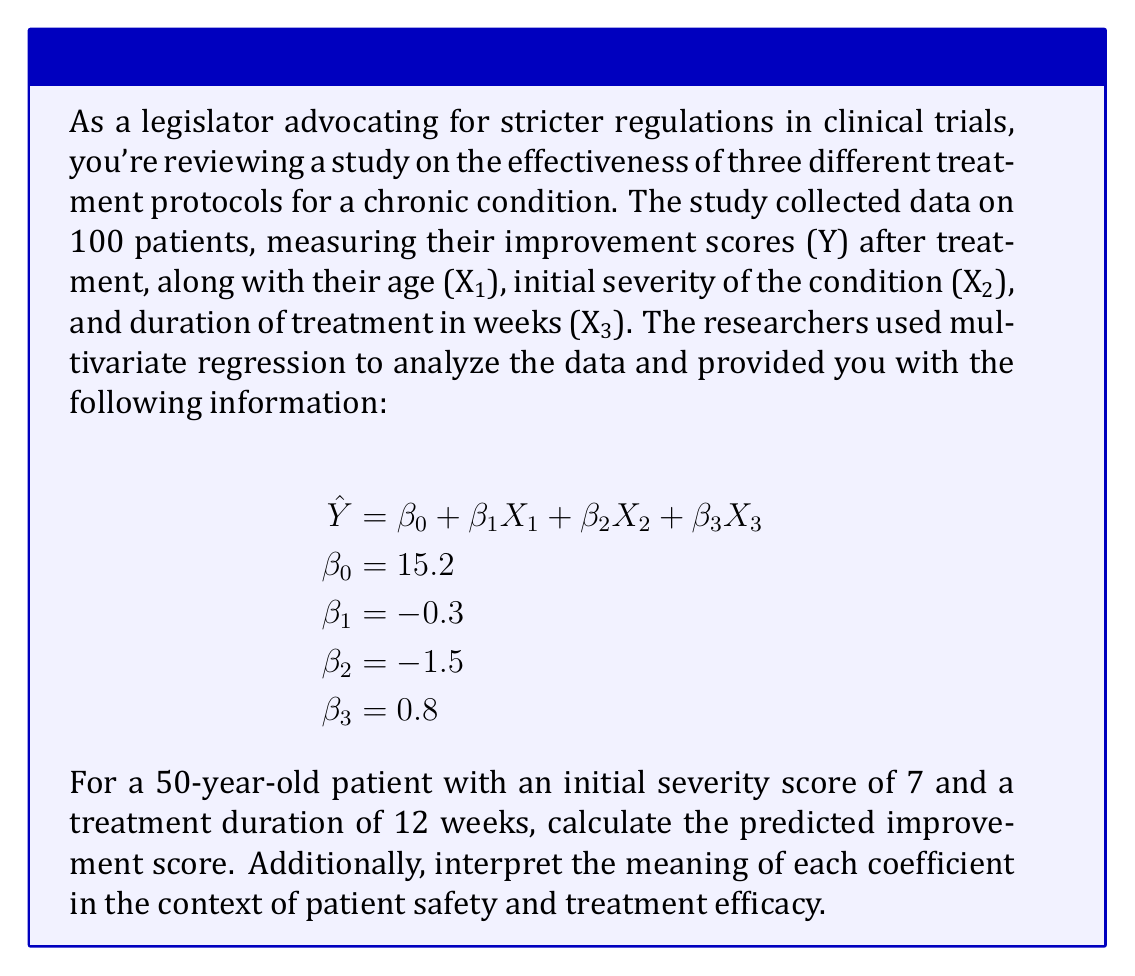Solve this math problem. To solve this problem and interpret the results, we'll follow these steps:

1. Calculate the predicted improvement score:
   We'll use the given regression equation and substitute the values for X1, X2, and X3.

   $$\begin{aligned}
   \hat{Y} &= \beta_0 + \beta_1X_1 + \beta_2X_2 + \beta_3X_3 \\
   &= 15.2 + (-0.3)(50) + (-1.5)(7) + (0.8)(12) \\
   &= 15.2 - 15 - 10.5 + 9.6 \\
   &= -0.7
   \end{aligned}$$

2. Interpret the coefficients:

   a) $\beta_0 = 15.2$: This is the intercept, representing the predicted improvement score when all other variables are zero. In practice, this may not have a meaningful interpretation as it's unlikely to have a patient with age 0 or initial severity 0.

   b) $\beta_1 = -0.3$: This coefficient represents the change in the improvement score for each year increase in age, holding other variables constant. The negative value suggests that older patients tend to show less improvement, which could be a concern for patient safety in older populations.

   c) $\beta_2 = -1.5$: This coefficient represents the change in the improvement score for each unit increase in initial severity, holding other variables constant. The negative value indicates that patients with higher initial severity tend to show less improvement. This could be crucial for assessing the efficacy of treatments for severe cases.

   d) $\beta_3 = 0.8$: This coefficient represents the change in the improvement score for each week increase in treatment duration, holding other variables constant. The positive value suggests that longer treatment durations are associated with greater improvement, which could inform decisions about optimal treatment lengths.

From a legislator's perspective focused on patient safety and treatment efficacy:

1. The age coefficient ($\beta_1$) suggests a need for special considerations or adjusted protocols for older patients.
2. The initial severity coefficient ($\beta_2$) indicates that current treatments may be less effective for severe cases, potentially necessitating the development of more targeted interventions.
3. The treatment duration coefficient ($\beta_3$) supports longer treatment periods, but it's important to balance this with potential risks of prolonged treatment.
Answer: The predicted improvement score for a 50-year-old patient with an initial severity score of 7 and a treatment duration of 12 weeks is -0.7. 

Interpretation of coefficients:
$\beta_0 = 15.2$: Baseline improvement score (limited practical interpretation)
$\beta_1 = -0.3$: Decrease in improvement score per year of age
$\beta_2 = -1.5$: Decrease in improvement score per unit of initial severity
$\beta_3 = 0.8$: Increase in improvement score per week of treatment 